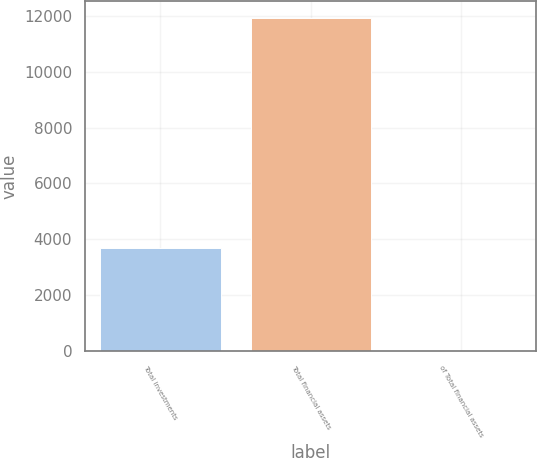<chart> <loc_0><loc_0><loc_500><loc_500><bar_chart><fcel>Total investments<fcel>Total financial assets<fcel>of Total financial assets<nl><fcel>3702<fcel>11941<fcel>11.4<nl></chart> 